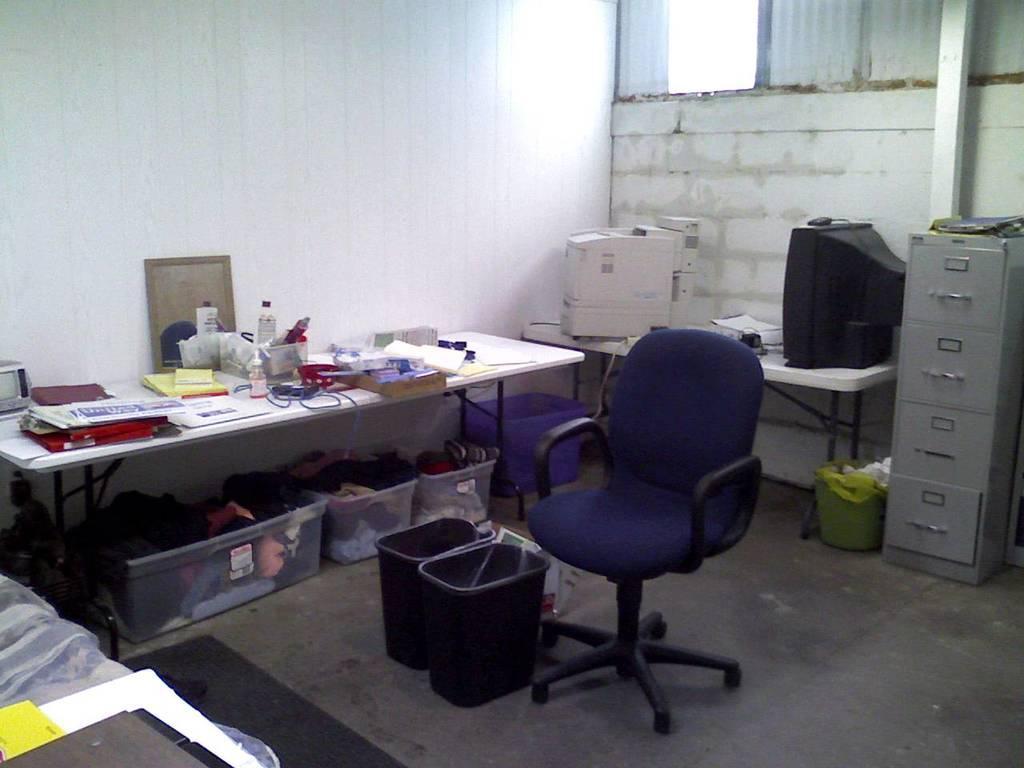How would you summarize this image in a sentence or two? This image is taken indoors. At the bottom of the image there is a floor. In the middle of the image there is an empty chair and dustbins. In the background there is a wall with a window. On the left side of the image there are two tables with many things on them and there are three baskets with a few clothes under the table. On the right side of the image there is a cupboard and a table with a monitor and a printer. 